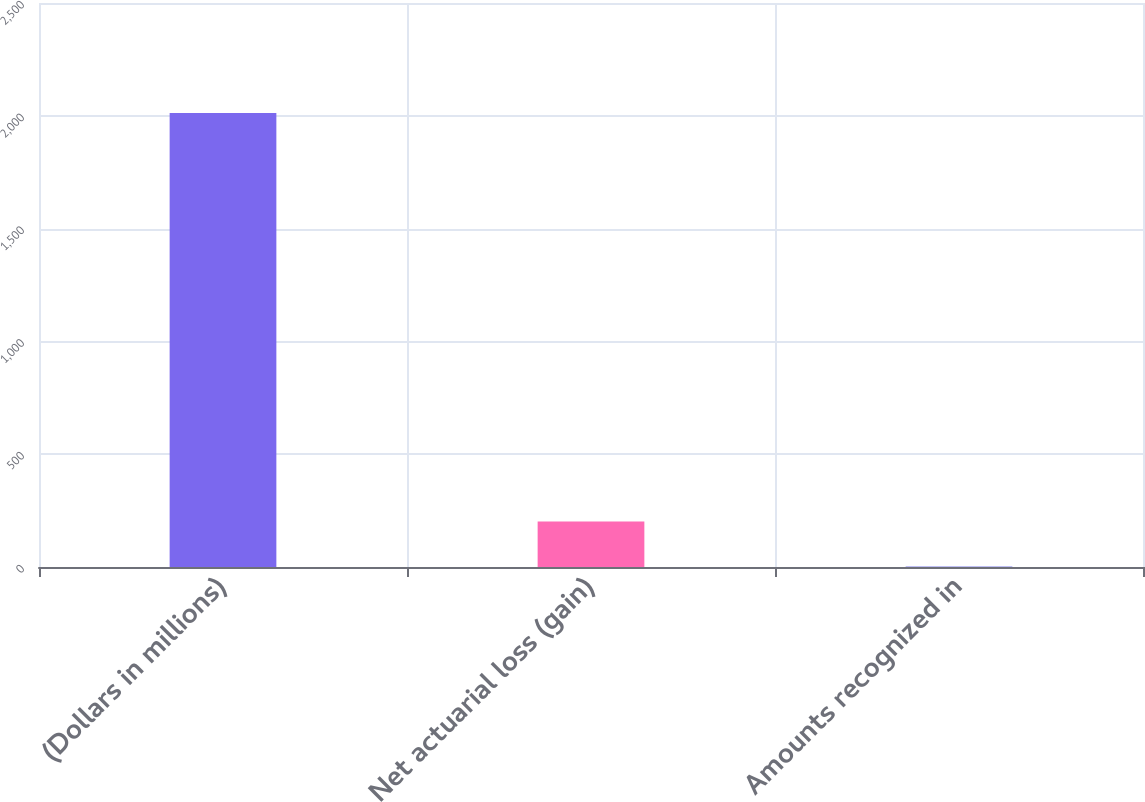Convert chart. <chart><loc_0><loc_0><loc_500><loc_500><bar_chart><fcel>(Dollars in millions)<fcel>Net actuarial loss (gain)<fcel>Amounts recognized in<nl><fcel>2012<fcel>202.1<fcel>1<nl></chart> 